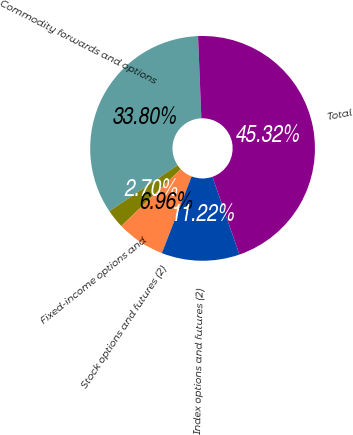Convert chart. <chart><loc_0><loc_0><loc_500><loc_500><pie_chart><fcel>Commodity forwards and options<fcel>Fixed-income options and<fcel>Stock options and futures (2)<fcel>Index options and futures (2)<fcel>Total<nl><fcel>33.8%<fcel>2.7%<fcel>6.96%<fcel>11.22%<fcel>45.32%<nl></chart> 